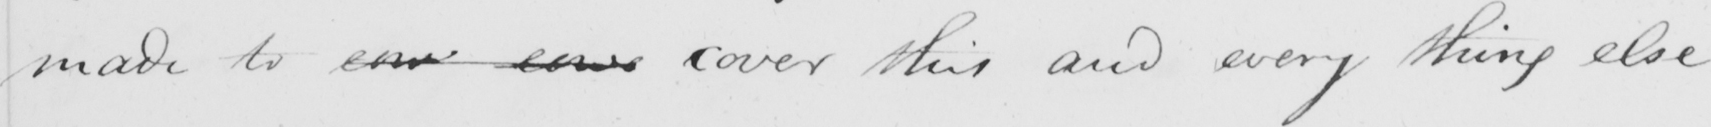Please provide the text content of this handwritten line. made to cow cowe cover this and every thing else 